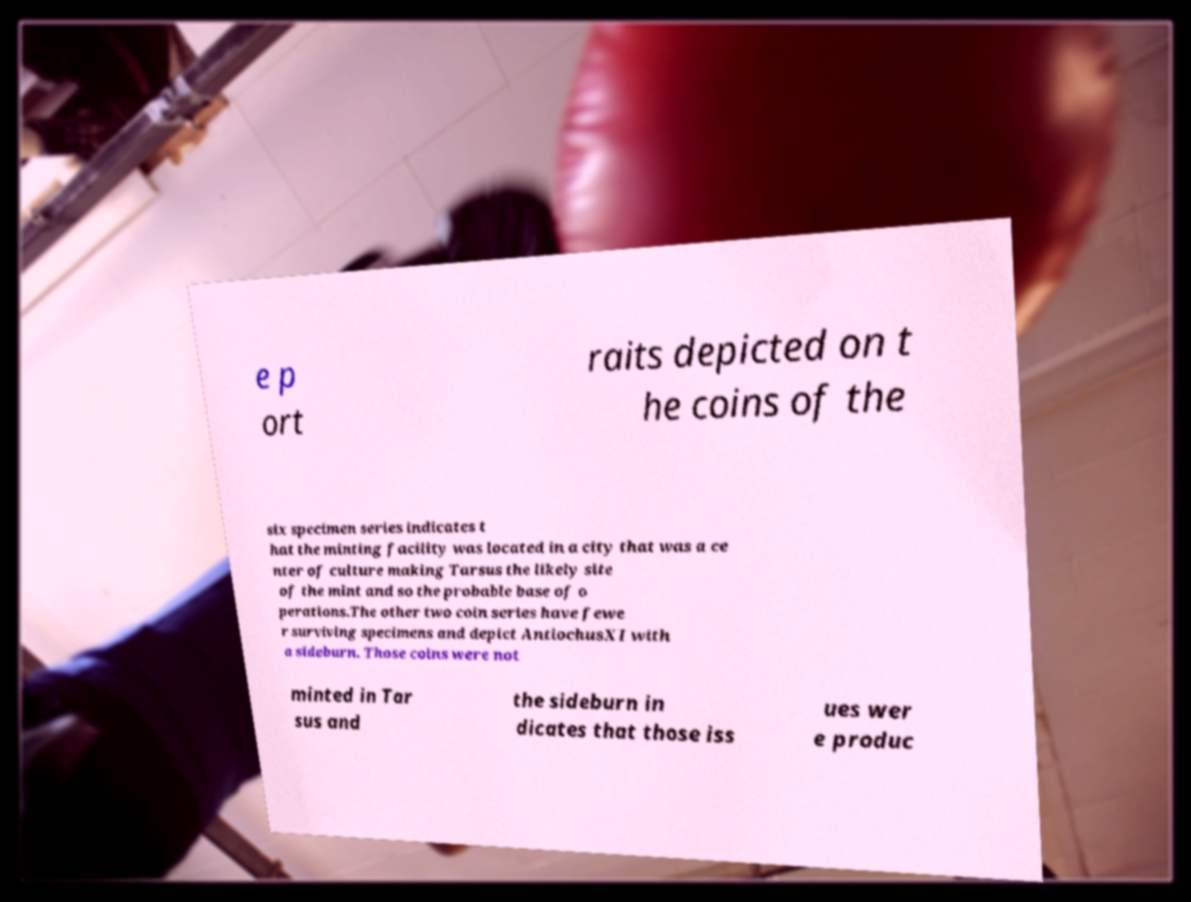What messages or text are displayed in this image? I need them in a readable, typed format. e p ort raits depicted on t he coins of the six specimen series indicates t hat the minting facility was located in a city that was a ce nter of culture making Tarsus the likely site of the mint and so the probable base of o perations.The other two coin series have fewe r surviving specimens and depict AntiochusXI with a sideburn. Those coins were not minted in Tar sus and the sideburn in dicates that those iss ues wer e produc 